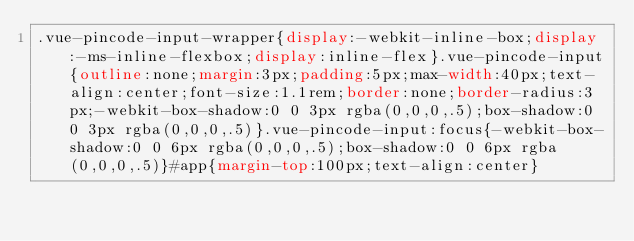Convert code to text. <code><loc_0><loc_0><loc_500><loc_500><_CSS_>.vue-pincode-input-wrapper{display:-webkit-inline-box;display:-ms-inline-flexbox;display:inline-flex}.vue-pincode-input{outline:none;margin:3px;padding:5px;max-width:40px;text-align:center;font-size:1.1rem;border:none;border-radius:3px;-webkit-box-shadow:0 0 3px rgba(0,0,0,.5);box-shadow:0 0 3px rgba(0,0,0,.5)}.vue-pincode-input:focus{-webkit-box-shadow:0 0 6px rgba(0,0,0,.5);box-shadow:0 0 6px rgba(0,0,0,.5)}#app{margin-top:100px;text-align:center}</code> 